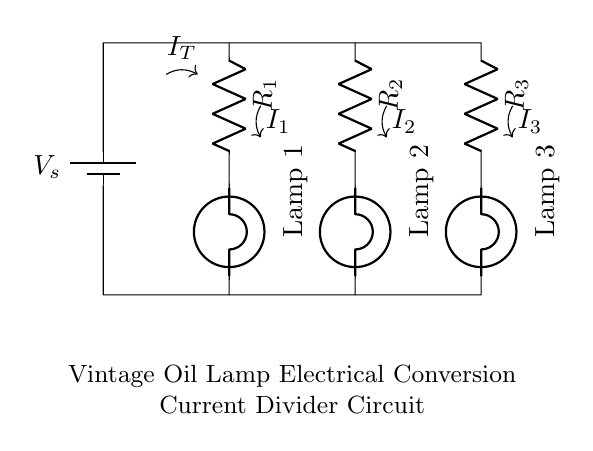What is the total current entering the circuit? The total current, represented by I_T, is the sum of the individual currents flowing through each branch of the circuit. In this circuit, it is shown as an arrow on the left side indicating the total outgoing current from the voltage source.
Answer: I_T What type of circuit is this? This circuit is a parallel circuit. In a parallel circuit, multiple paths exist for current to flow, which is evident as each lamp has its resistor and they are connected across the same voltage source.
Answer: Parallel How many resistors are in the circuit? There are three resistors labeled R1, R2, and R3 connected in parallel, as seen from their placement in the circuit diagram.
Answer: 3 Which lamp has the highest voltage? All lamps in a parallel circuit share the same voltage from the source, making them equal. Thus, every lamp (Lamp 1, Lamp 2, and Lamp 3) has the same voltage across it.
Answer: Equal What happens to the current when one lamp is removed? When one lamp is removed, the total current from the source will increase as the total resistance of the circuit decreases, due to the remaining resistors still providing pathways for current to flow. This can be reasoned from the current divider rule, where less resistance results in higher total current.
Answer: Increases What is the role of the resistors in the circuit? The resistors (R1, R2, R3) are used to limit the current flowing through each lamp, ensuring they operate safely without burning out. In parallel circuits, they also help divide the current amongst the pathways provided.
Answer: Limit current 